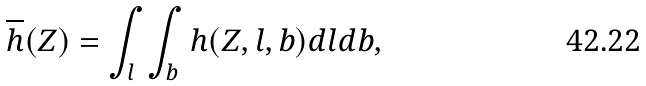<formula> <loc_0><loc_0><loc_500><loc_500>\overline { h } ( Z ) = \int _ { l } \, \int _ { b } \, h ( Z , l , b ) d l d b ,</formula> 